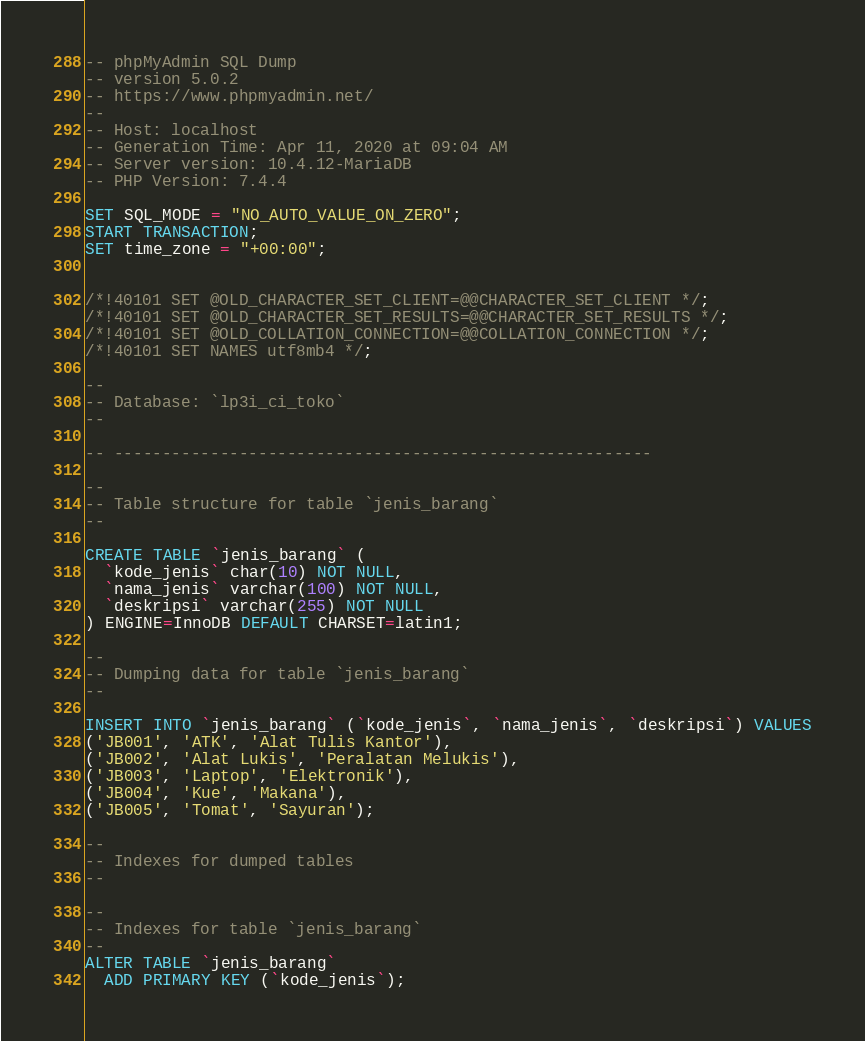<code> <loc_0><loc_0><loc_500><loc_500><_SQL_>-- phpMyAdmin SQL Dump
-- version 5.0.2
-- https://www.phpmyadmin.net/
--
-- Host: localhost
-- Generation Time: Apr 11, 2020 at 09:04 AM
-- Server version: 10.4.12-MariaDB
-- PHP Version: 7.4.4

SET SQL_MODE = "NO_AUTO_VALUE_ON_ZERO";
START TRANSACTION;
SET time_zone = "+00:00";


/*!40101 SET @OLD_CHARACTER_SET_CLIENT=@@CHARACTER_SET_CLIENT */;
/*!40101 SET @OLD_CHARACTER_SET_RESULTS=@@CHARACTER_SET_RESULTS */;
/*!40101 SET @OLD_COLLATION_CONNECTION=@@COLLATION_CONNECTION */;
/*!40101 SET NAMES utf8mb4 */;

--
-- Database: `lp3i_ci_toko`
--

-- --------------------------------------------------------

--
-- Table structure for table `jenis_barang`
--

CREATE TABLE `jenis_barang` (
  `kode_jenis` char(10) NOT NULL,
  `nama_jenis` varchar(100) NOT NULL,
  `deskripsi` varchar(255) NOT NULL
) ENGINE=InnoDB DEFAULT CHARSET=latin1;

--
-- Dumping data for table `jenis_barang`
--

INSERT INTO `jenis_barang` (`kode_jenis`, `nama_jenis`, `deskripsi`) VALUES
('JB001', 'ATK', 'Alat Tulis Kantor'),
('JB002', 'Alat Lukis', 'Peralatan Melukis'),
('JB003', 'Laptop', 'Elektronik'),
('JB004', 'Kue', 'Makana'),
('JB005', 'Tomat', 'Sayuran');

--
-- Indexes for dumped tables
--

--
-- Indexes for table `jenis_barang`
--
ALTER TABLE `jenis_barang`
  ADD PRIMARY KEY (`kode_jenis`);</code> 